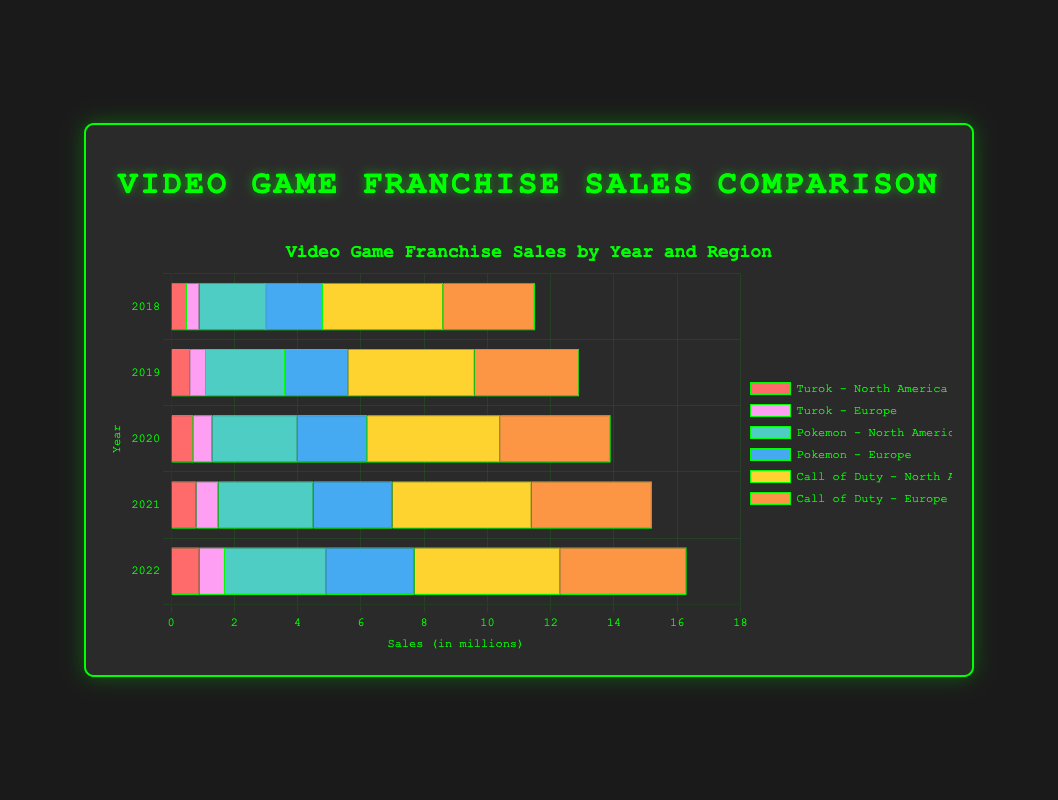What is the trend in Turok sales in North America from 2018 to 2022? To identify the trend, look at the sales values for Turok in North America from 2018 to 2022. The sales are 0.5 (2018), 0.6 (2019), 0.7 (2020), 0.8 (2021), and 0.9 (2022). The sales are consistently increasing each year.
Answer: Increasing Which year had the highest sales for Call of Duty in Europe? Check the sales values for Call of Duty in Europe for each year. The sales are 2.9 (2018), 3.3 (2019), 3.5 (2020), 3.8 (2021), and 4.0 (2022). The highest sales occurred in 2022.
Answer: 2022 Are the sales of Pokemon in North America in 2020 greater than or less than 3.0 million? Look at the bar entries for Pokemon in North America for 2020. The sales figure is 2.7 million, which is less than 3.0 million.
Answer: Less than 3.0 million What is the average sales for Turok in Europe from 2018 to 2022? The sales for Turok in Europe from 2018 to 2022 are 0.4, 0.5, 0.6, 0.7, and 0.8. Sum these values to get 3.0, and then divide by 5 to find the average. The average sales is 3.0 / 5 = 0.6.
Answer: 0.6 How do the sales of Call of Duty in North America compare to Europe in 2021? In 2021, the sales of Call of Duty in North America are 4.4 million and in Europe are 3.8 million. The sales in North America are higher than in Europe by 4.4 - 3.8 = 0.6 million.
Answer: 0.6 million higher Which franchise had the lowest sales in Europe in 2020? In Europe in 2020, the sales are: Turok (0.6), Pokemon (2.2), Call of Duty (3.5). Turok has the lowest sales at 0.6 million.
Answer: Turok What is the total sales of Pokemon in both regions combined for the year 2019? For 2019, the sales of Pokemon are 2.5 million in North America and 2.0 million in Europe. Add these values to get 2.5 + 2.0 = 4.5 million.
Answer: 4.5 million How does the growth in sales of Turok in North America from 2019 to 2020 compare to the growth from 2020 to 2021? The growth from 2019 to 2020 is 0.7 - 0.6 = 0.1 million. The growth from 2020 to 2021 is 0.8 - 0.7 = 0.1 million. Both growth intervals are the same.
Answer: The same Which franchise had the highest overall sales in 2022? In 2022, check the sales of all franchises in both regions. Turok: North America (0.9), Europe (0.8); Pokemon: North America (3.2), Europe (2.8); Call of Duty: North America (4.6), Europe (4.0). The highest overall sales are for Call of Duty at 4.6 + 4.0 = 8.6 million.
Answer: Call of Duty What is the difference in sales of Pokemon in North America between the years 2019 and 2021? The sales of Pokemon in North America in 2019 is 2.5 million, and in 2021 is 3.0 million. The difference is 3.0 - 2.5 = 0.5 million.
Answer: 0.5 million 